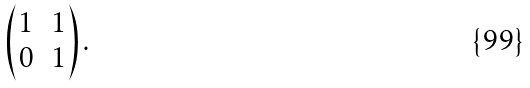Convert formula to latex. <formula><loc_0><loc_0><loc_500><loc_500>\begin{pmatrix} 1 & 1 \\ 0 & 1 \end{pmatrix} .</formula> 